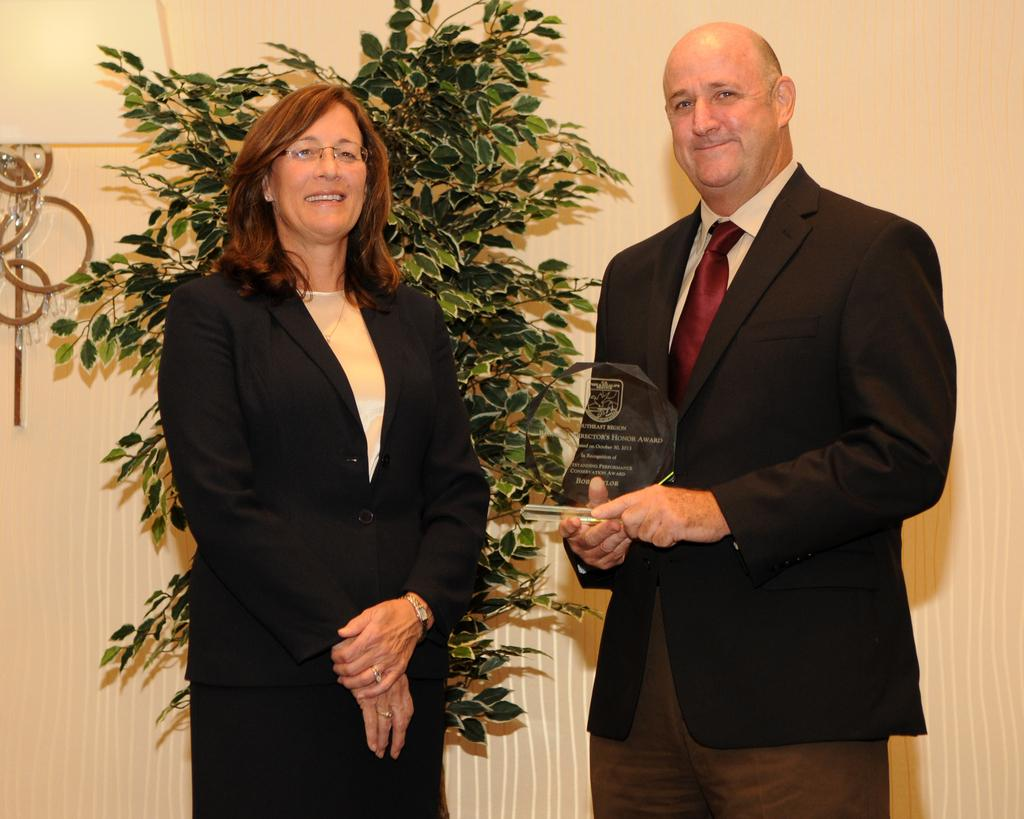How many people are in the image? There are two persons in the image. What is one person holding in the image? One person is holding a shield. What type of vegetation is present in the image? There is a potted plant visible in the image. What type of yak can be seen in the image? There is no yak present in the image. How many cows are visible in the image? There are no cows visible in the image. 